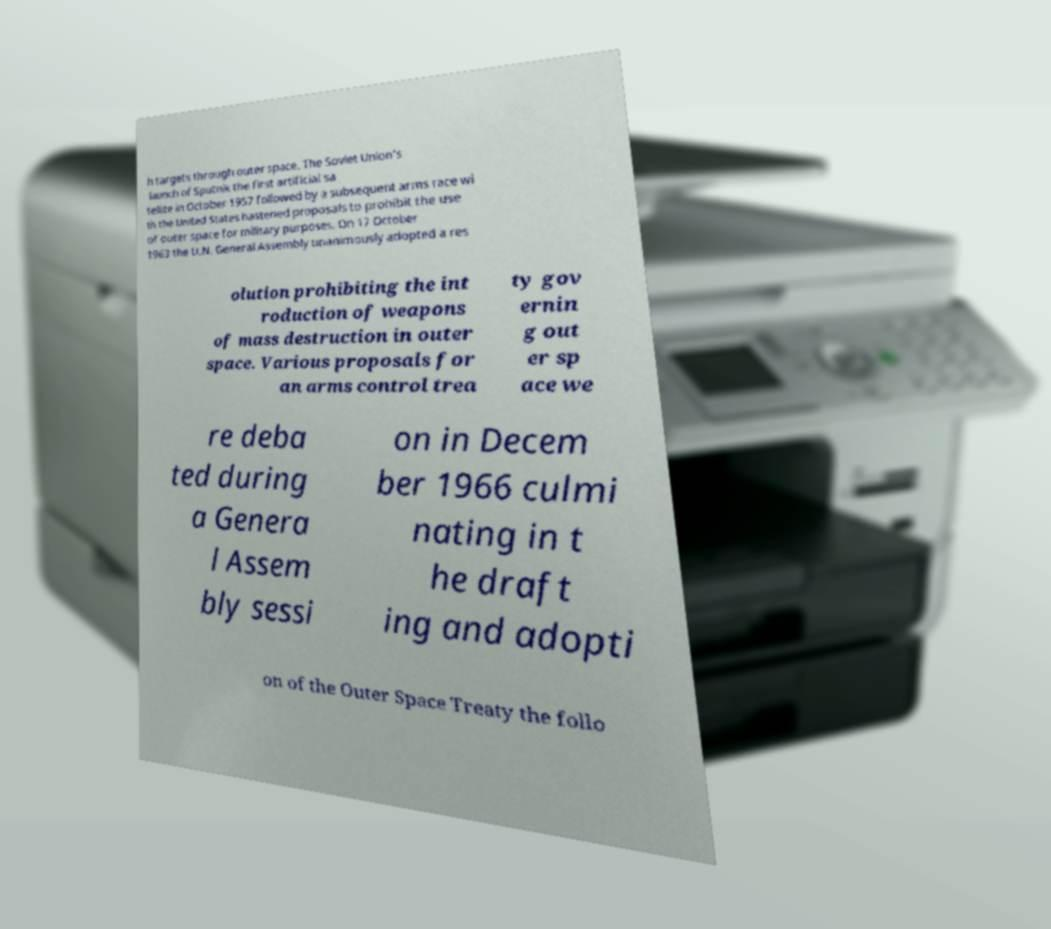I need the written content from this picture converted into text. Can you do that? h targets through outer space. The Soviet Union's launch of Sputnik the first artificial sa tellite in October 1957 followed by a subsequent arms race wi th the United States hastened proposals to prohibit the use of outer space for military purposes. On 17 October 1963 the U.N. General Assembly unanimously adopted a res olution prohibiting the int roduction of weapons of mass destruction in outer space. Various proposals for an arms control trea ty gov ernin g out er sp ace we re deba ted during a Genera l Assem bly sessi on in Decem ber 1966 culmi nating in t he draft ing and adopti on of the Outer Space Treaty the follo 